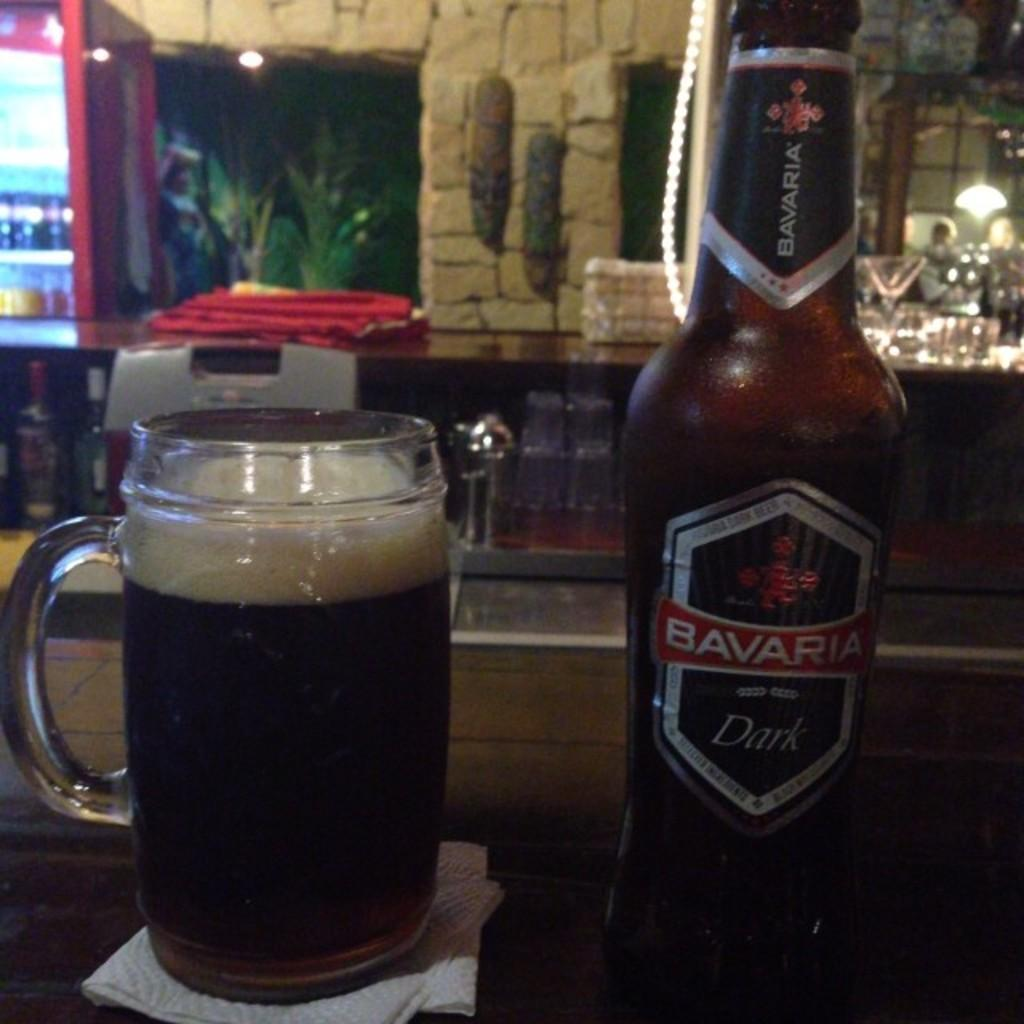<image>
Summarize the visual content of the image. A bottle of Bavaris dark ale sits next to a glass full of the same liquid on a bar in a pub. 